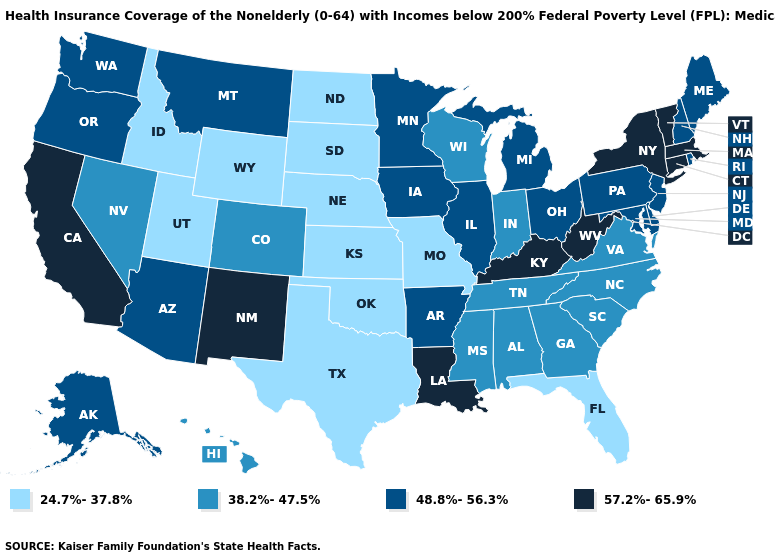Name the states that have a value in the range 24.7%-37.8%?
Short answer required. Florida, Idaho, Kansas, Missouri, Nebraska, North Dakota, Oklahoma, South Dakota, Texas, Utah, Wyoming. What is the value of Alaska?
Concise answer only. 48.8%-56.3%. Which states hav the highest value in the West?
Write a very short answer. California, New Mexico. Does Nebraska have the same value as Virginia?
Short answer required. No. What is the value of Ohio?
Keep it brief. 48.8%-56.3%. Among the states that border Kentucky , does Missouri have the lowest value?
Give a very brief answer. Yes. What is the value of South Carolina?
Concise answer only. 38.2%-47.5%. What is the value of Nebraska?
Write a very short answer. 24.7%-37.8%. How many symbols are there in the legend?
Concise answer only. 4. What is the lowest value in the USA?
Concise answer only. 24.7%-37.8%. Does Nevada have a lower value than Indiana?
Give a very brief answer. No. What is the value of Pennsylvania?
Give a very brief answer. 48.8%-56.3%. Name the states that have a value in the range 38.2%-47.5%?
Keep it brief. Alabama, Colorado, Georgia, Hawaii, Indiana, Mississippi, Nevada, North Carolina, South Carolina, Tennessee, Virginia, Wisconsin. How many symbols are there in the legend?
Short answer required. 4. Which states have the lowest value in the Northeast?
Quick response, please. Maine, New Hampshire, New Jersey, Pennsylvania, Rhode Island. 